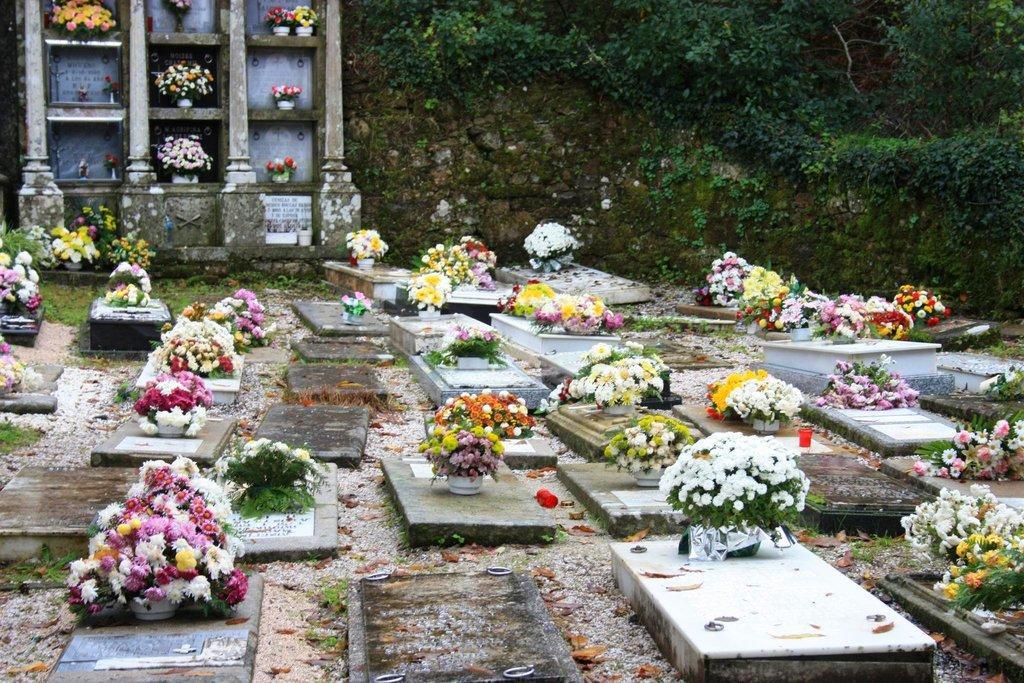In one or two sentences, can you explain what this image depicts? In this image we can see some flower bouquets on the graves, there are some leaves on the ground, also we can see the plants. 